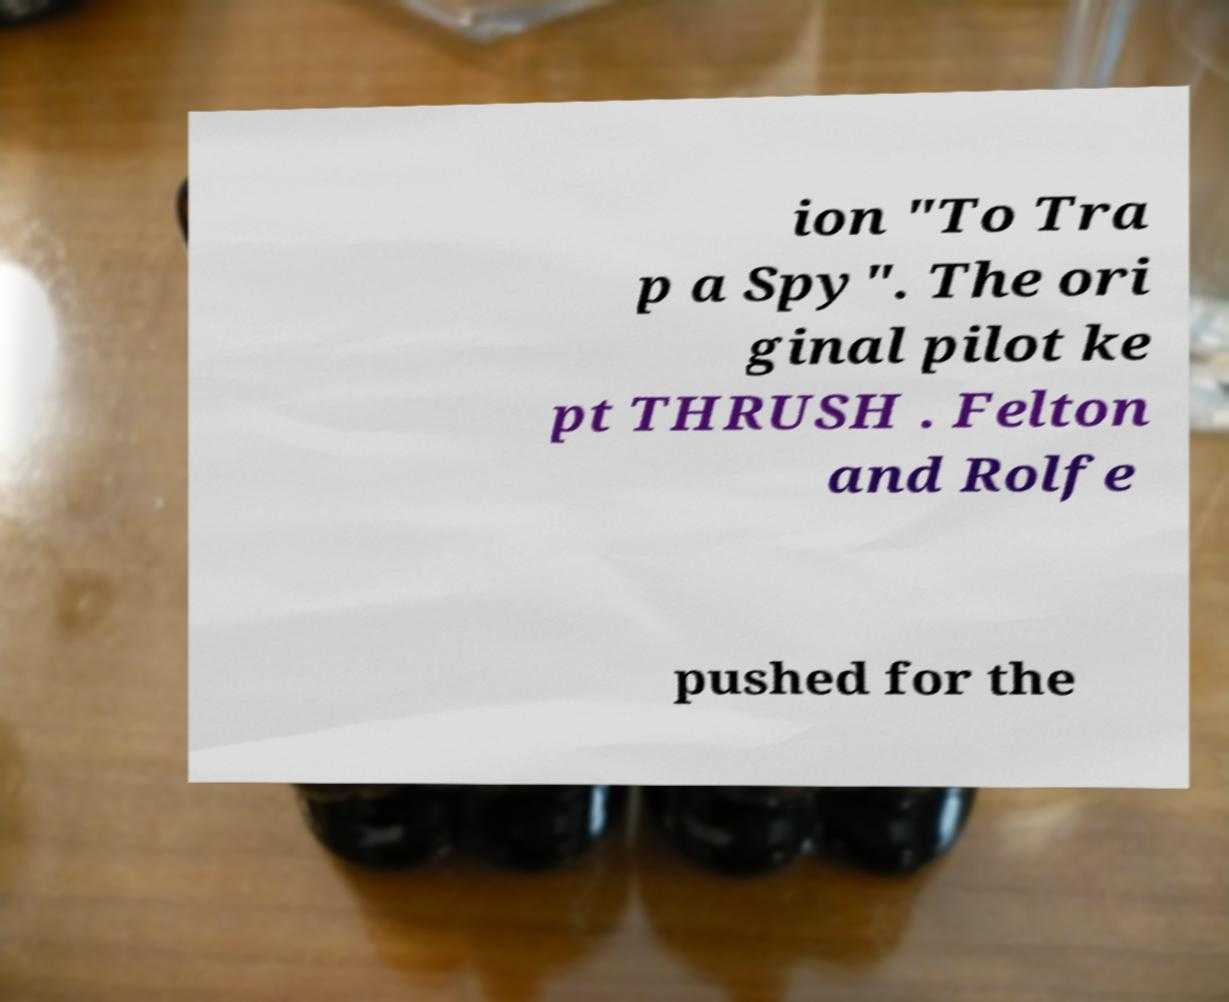There's text embedded in this image that I need extracted. Can you transcribe it verbatim? ion "To Tra p a Spy". The ori ginal pilot ke pt THRUSH . Felton and Rolfe pushed for the 